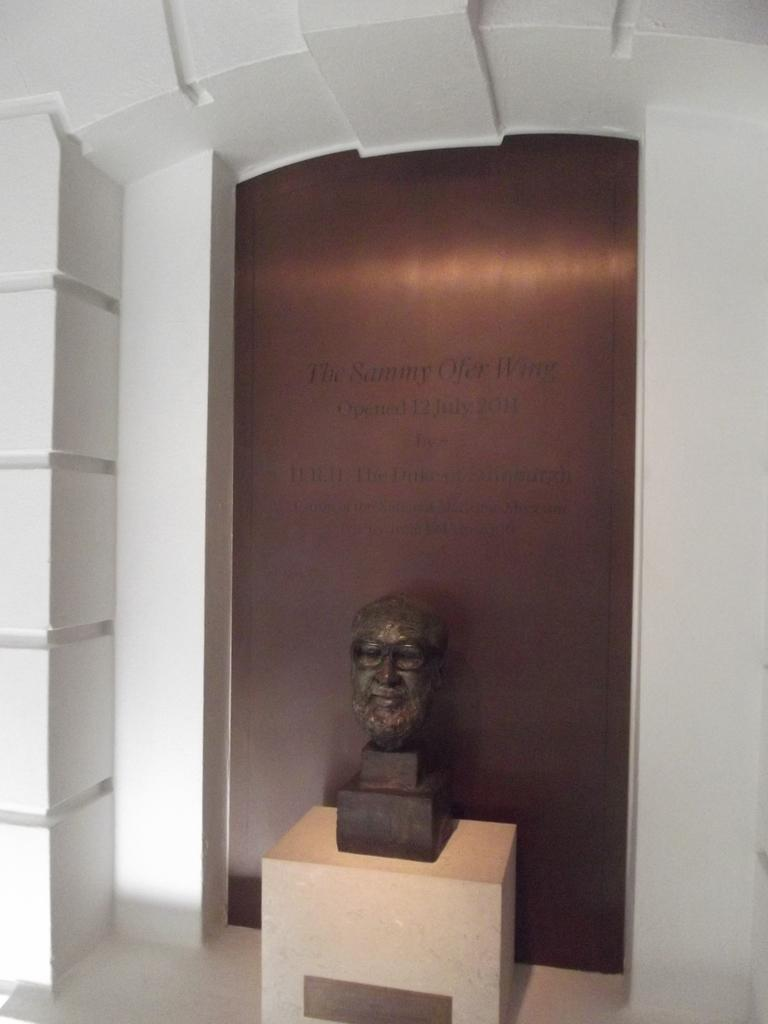What type of material is present in the image? There is lay stone in the image. What other object can be seen in the image? There is a statue in the image. What type of corn is growing in the image? There is no corn present in the image; it features lay stone and a statue. What kind of lead can be seen in the image? There is no lead present in the image. 